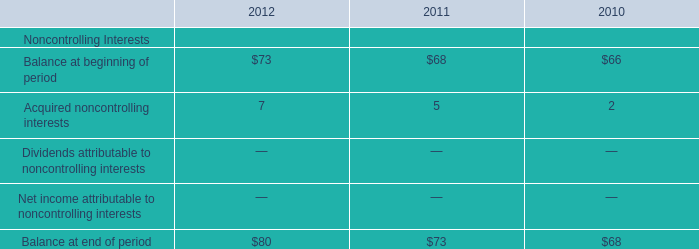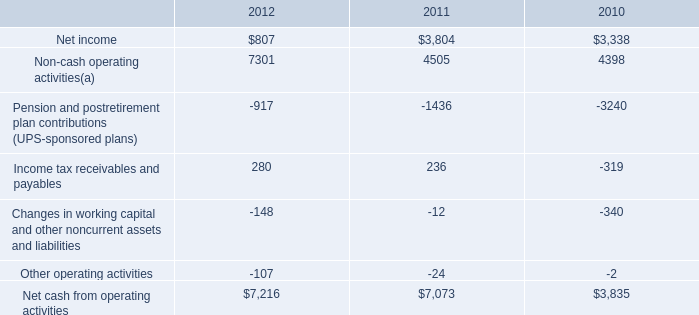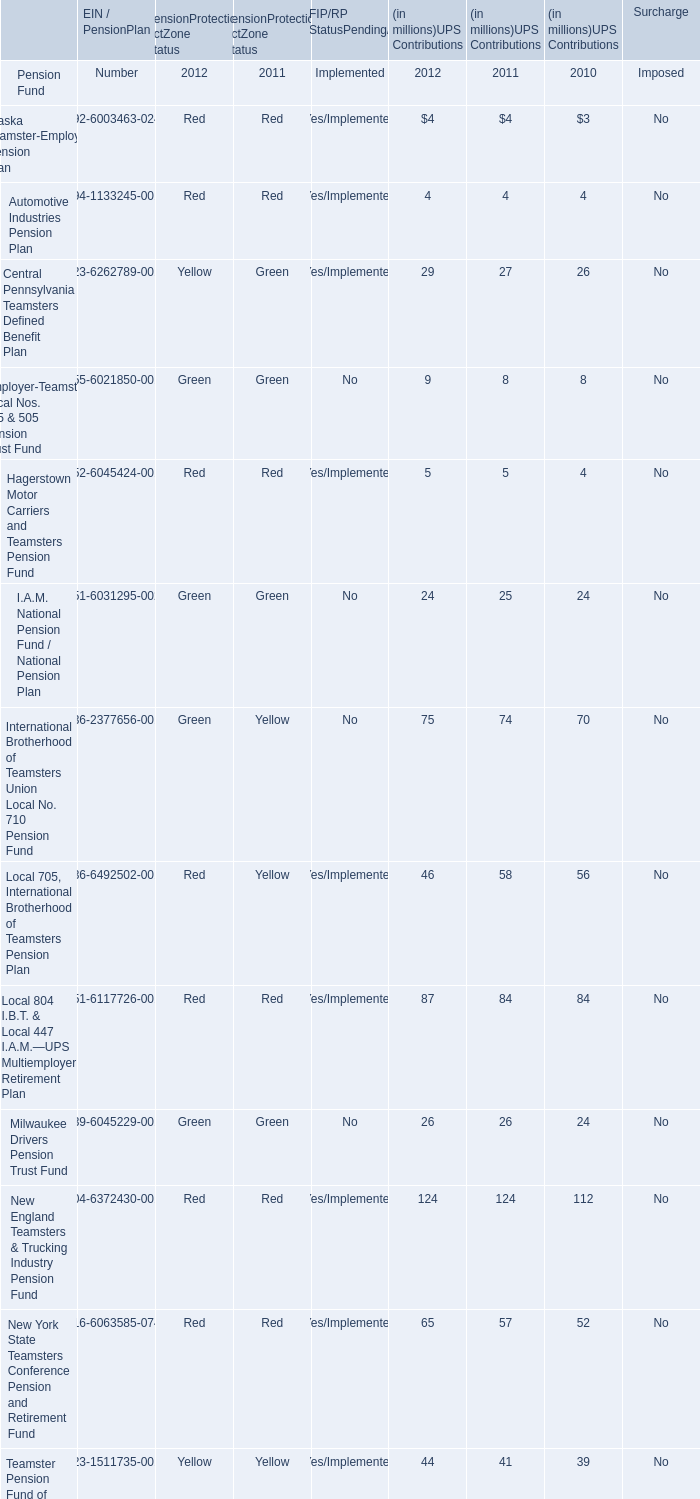What was the average of the Milwaukee Drivers Pension Trust Fund for UPS Contributions in the years where Automotive Industries Pension Plan for UPS Contributions is positive? 
Computations: (((26 + 26) + 24) / 3)
Answer: 25.33333. 